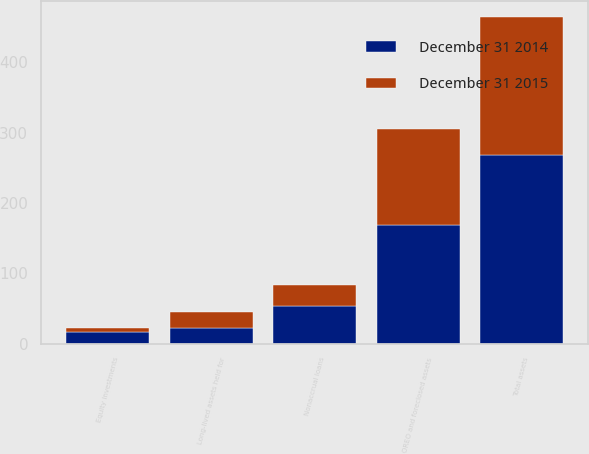<chart> <loc_0><loc_0><loc_500><loc_500><stacked_bar_chart><ecel><fcel>Nonaccrual loans<fcel>Equity investments<fcel>OREO and foreclosed assets<fcel>Long-lived assets held for<fcel>Total assets<nl><fcel>December 31 2015<fcel>30<fcel>5<fcel>137<fcel>23<fcel>195<nl><fcel>December 31 2014<fcel>54<fcel>17<fcel>168<fcel>22<fcel>269<nl></chart> 